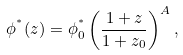<formula> <loc_0><loc_0><loc_500><loc_500>\phi ^ { ^ { * } } ( z ) = \phi ^ { ^ { * } } _ { 0 } \left ( \frac { 1 + z } { 1 + z _ { 0 } } \right ) ^ { A } ,</formula> 